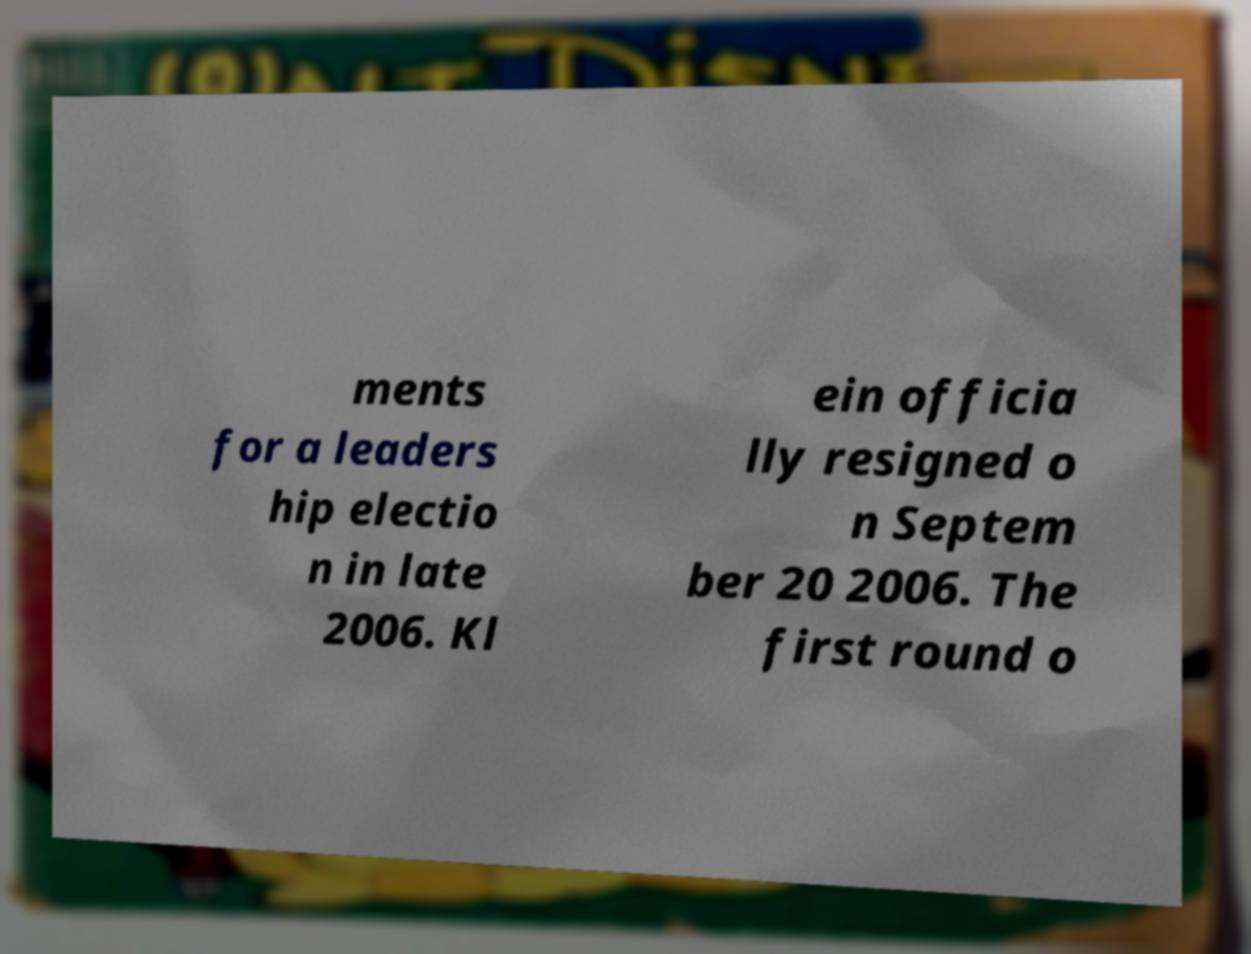Please identify and transcribe the text found in this image. ments for a leaders hip electio n in late 2006. Kl ein officia lly resigned o n Septem ber 20 2006. The first round o 